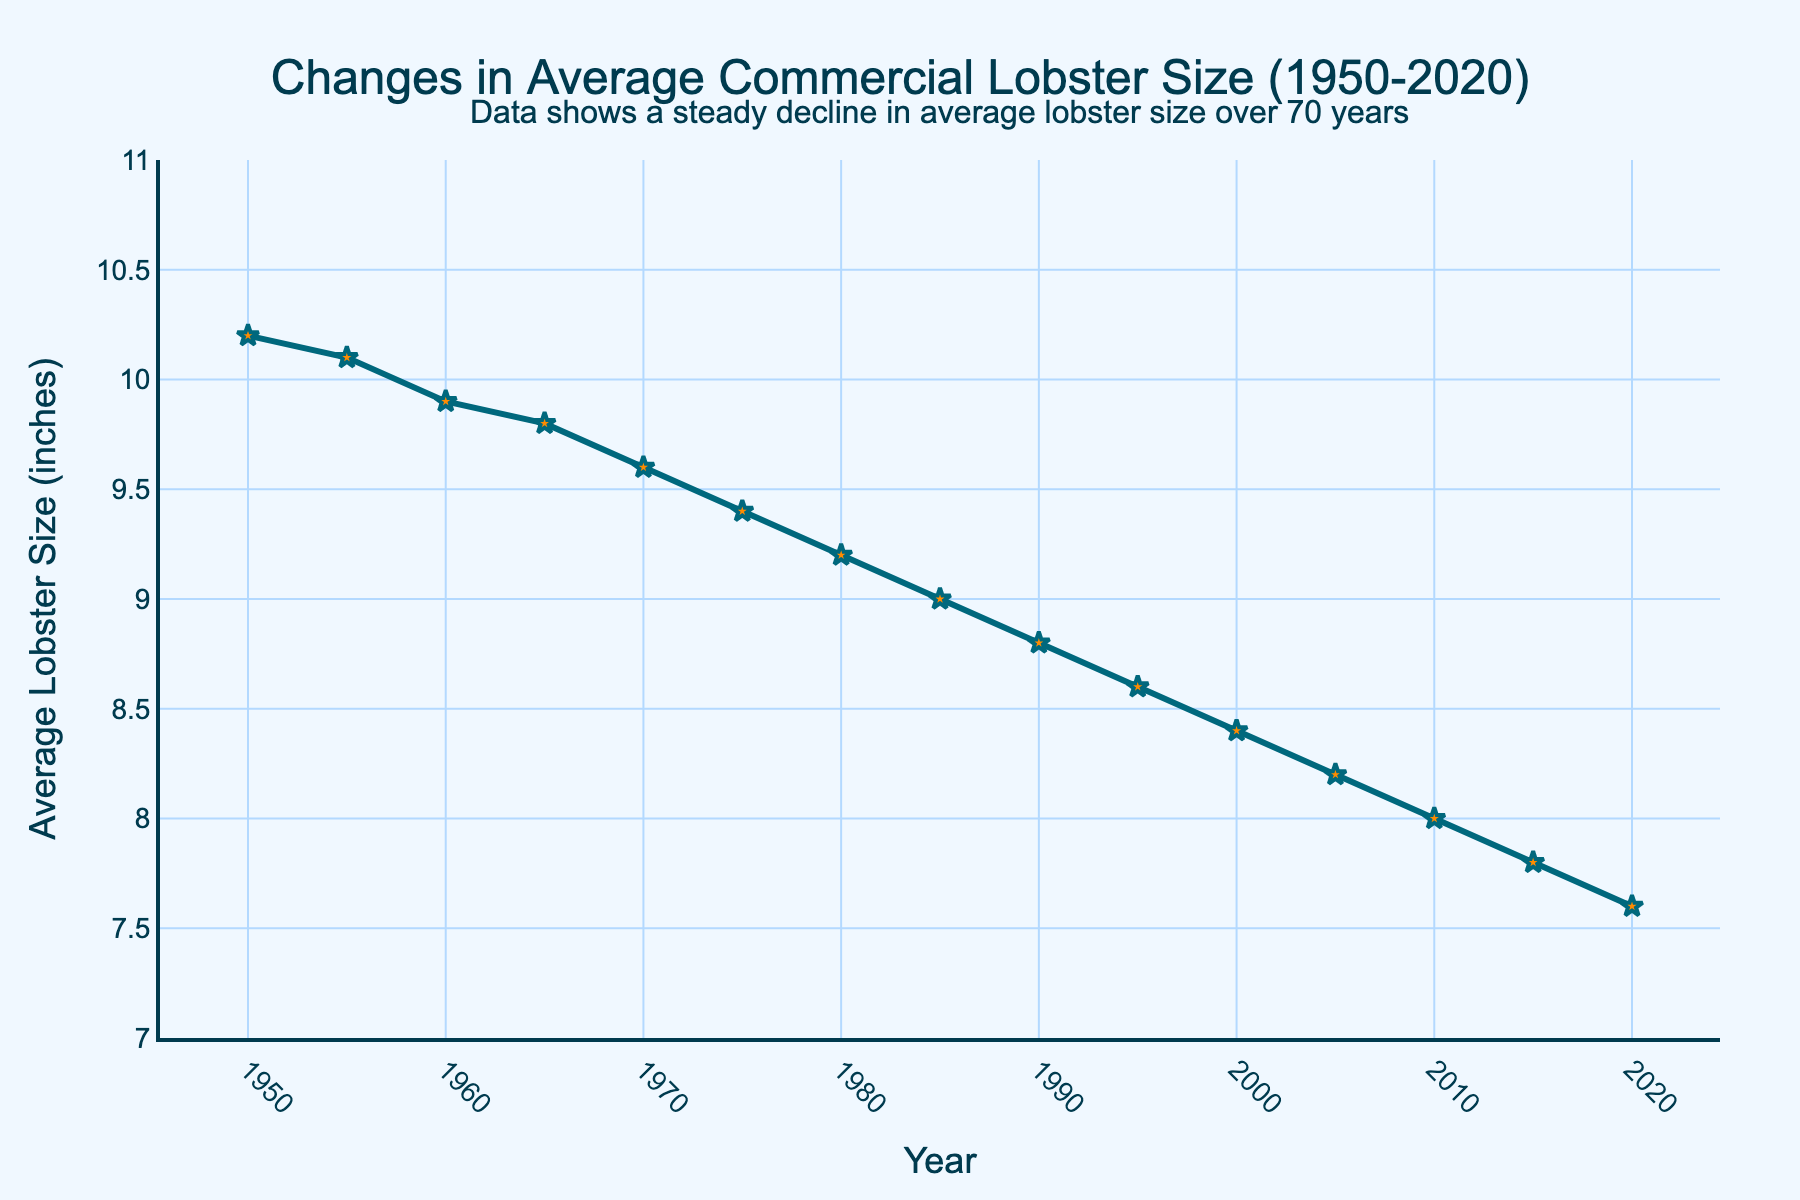What is the average size of lobsters caught in 1980? According to the line chart, the average size of lobsters caught in 1980 is marked on the y-axis corresponding to this year.
Answer: 9.2 inches How much did the average lobster size decrease from 1950 to 2020? Subtract the average lobster size in 2020 (7.6 inches) from the average size in 1950 (10.2 inches). The decrease is 10.2 - 7.6 = 2.6 inches.
Answer: 2.6 inches In which year did the average lobster size first drop below 9 inches? Trace the line chart and look for the first point where the y-value is below 9 inches. This happens in 1985 where the average lobster size is 9.0 inches.
Answer: 1990 How much did the average lobster size change between 1960 and 2000? Find the average sizes in 1960 (9.9 inches) and 2000 (8.4 inches), then compute the difference: 9.9 - 8.4 = 1.5 inches.
Answer: 1.5 inches Which decade experienced the largest decrease in average lobster size? Calculate the decrease for each decade: 1950-1960 (10.2 to 9.9, decrease of 0.3), 1960-1970 (9.9 to 9.6, decrease of 0.3), 1970-1980 (9.6 to 9.2, decrease of 0.4), 1980-1990 (9.0 to 8.8, decrease of 0.2), 1990-2000 (8.8 to 8.4, decrease of 0.4), 2000-2010 (8.4 to 8.0, decrease of 0.4), 2010-2020 (8.0 to 7.6, decrease of 0.4). The largest decrease occurred in 1970-1980, 1990-2000, 2000-2010, and 2010-2020 with a decrease of 0.4 each.
Answer: 1970-1980, 1990-2000, 2000-2010, and 2010-2020 Is the rate of decrease in lobster size steady over the years? Analyze the trend line and see if the slope is consistent. The line appears to show a steady decrease, indicating the rate of decrease is fairly consistent.
Answer: Yes What is the visual representation of the lobster sizes in the chart? The lobster sizes are represented by a line chart with markers. The line is colored dark blue, and the markers are orange stars with a blue outline.
Answer: Line with orange star markers Can you identify the period with the smallest change in average lobster size? Compare the change for each period specified on the x-axis by reviewing the differences in inches. The smallest change is between 1980 and 1985 (0.2 inches) and 1990 and 1995 (0.2 inches).
Answer: 1980-1985 and 1990-1995 